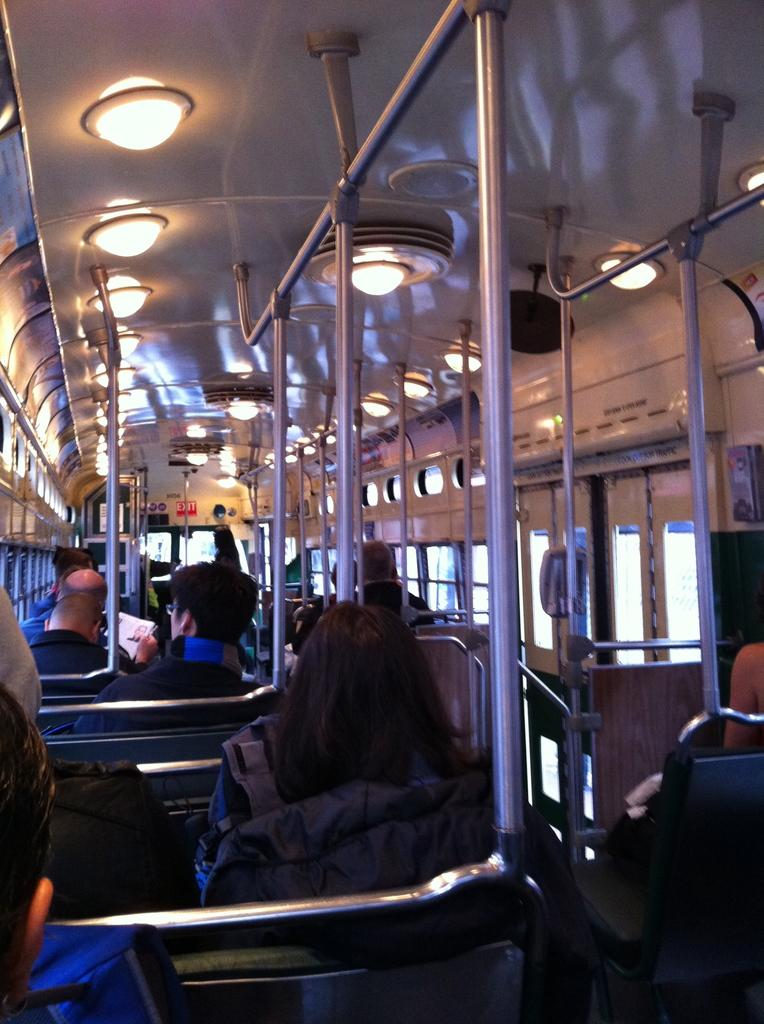What is happening in the image? There are people sitting in a vehicle. What type of view does the image provide? The image is an inside view of the vehicle. What can be seen in the vehicle besides the people? There are lights, metal rods, windows, and other objects visible in the vehicle. What type of mist can be seen coming from the bit in the image? There is no bit or mist present in the image; it is an inside view of a vehicle with people sitting in it. 